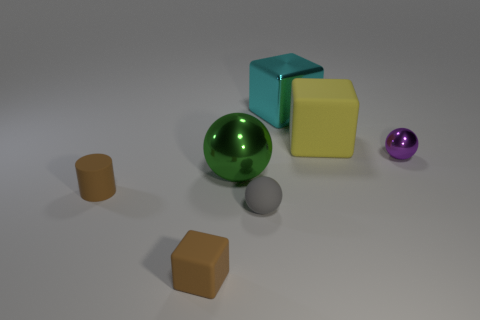Could you describe the lighting in the scene? The lighting in the image is soft and diffused, suggesting an overcast sky or ambient lighting in an interior setting. There are no harsh shadows, and the highlights on the objects are gentle and rounded, which adds to the calm and controlled atmosphere of the scene. How does the lighting affect the colors of the objects? The soft lighting allows the inherent colors of the objects to show without significant alteration. The colors appear true to life and saturated but not overly so. The light lets the texture of the objects be visible, which helps in distinguishing the matte from the shiny surfaces. 